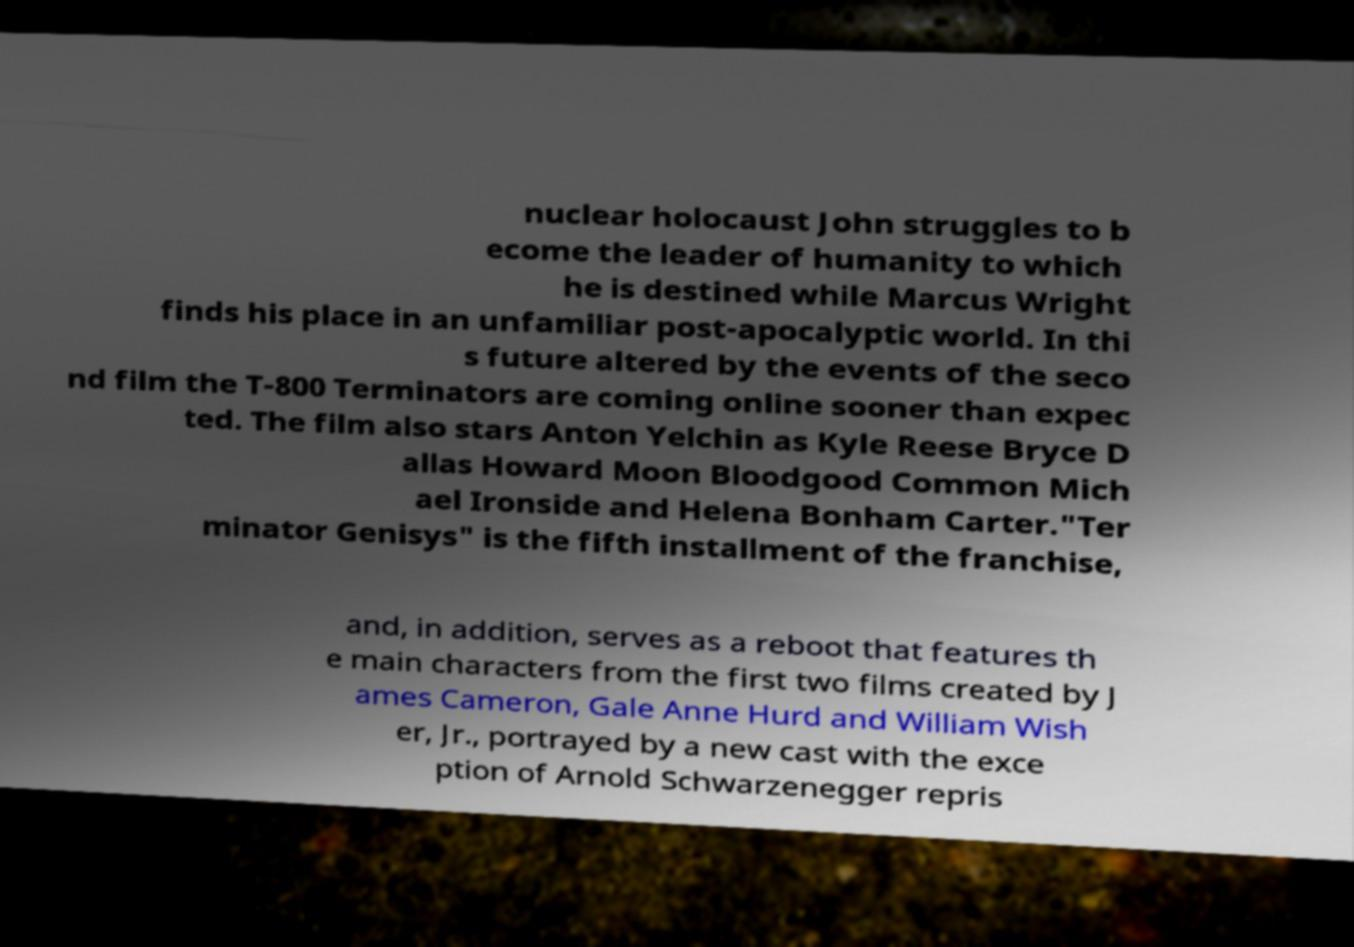I need the written content from this picture converted into text. Can you do that? nuclear holocaust John struggles to b ecome the leader of humanity to which he is destined while Marcus Wright finds his place in an unfamiliar post-apocalyptic world. In thi s future altered by the events of the seco nd film the T-800 Terminators are coming online sooner than expec ted. The film also stars Anton Yelchin as Kyle Reese Bryce D allas Howard Moon Bloodgood Common Mich ael Ironside and Helena Bonham Carter."Ter minator Genisys" is the fifth installment of the franchise, and, in addition, serves as a reboot that features th e main characters from the first two films created by J ames Cameron, Gale Anne Hurd and William Wish er, Jr., portrayed by a new cast with the exce ption of Arnold Schwarzenegger repris 